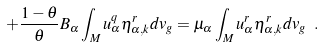<formula> <loc_0><loc_0><loc_500><loc_500>+ \frac { 1 - \theta } { \theta } B _ { \alpha } \int _ { M } u _ { \alpha } ^ { q } \eta _ { \alpha , k } ^ { r } d v _ { g } = \mu _ { \alpha } \int _ { M } u _ { \alpha } ^ { r } \eta _ { \alpha , k } ^ { r } d v _ { g } \ .</formula> 